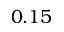Convert formula to latex. <formula><loc_0><loc_0><loc_500><loc_500>0 . 1 5</formula> 